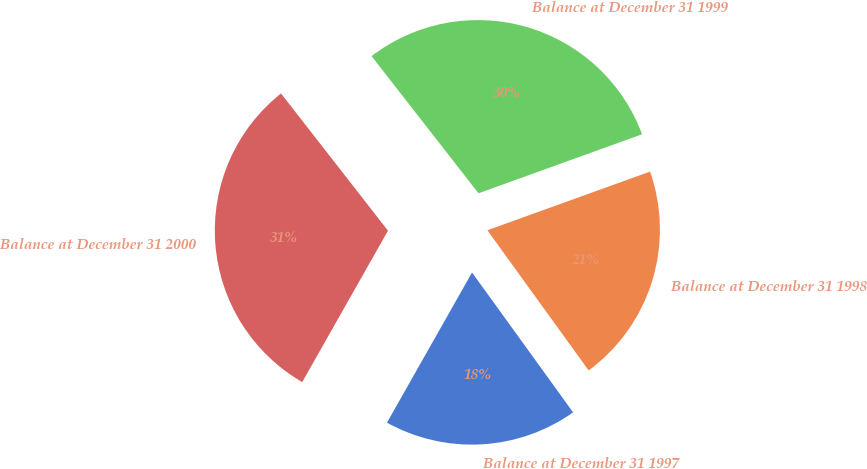Convert chart to OTSL. <chart><loc_0><loc_0><loc_500><loc_500><pie_chart><fcel>Balance at December 31 1997<fcel>Balance at December 31 1998<fcel>Balance at December 31 1999<fcel>Balance at December 31 2000<nl><fcel>18.16%<fcel>20.55%<fcel>30.03%<fcel>31.26%<nl></chart> 